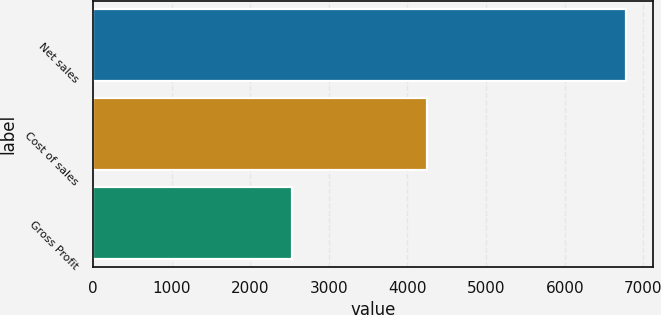Convert chart to OTSL. <chart><loc_0><loc_0><loc_500><loc_500><bar_chart><fcel>Net sales<fcel>Cost of sales<fcel>Gross Profit<nl><fcel>6778.3<fcel>4246.7<fcel>2531.6<nl></chart> 